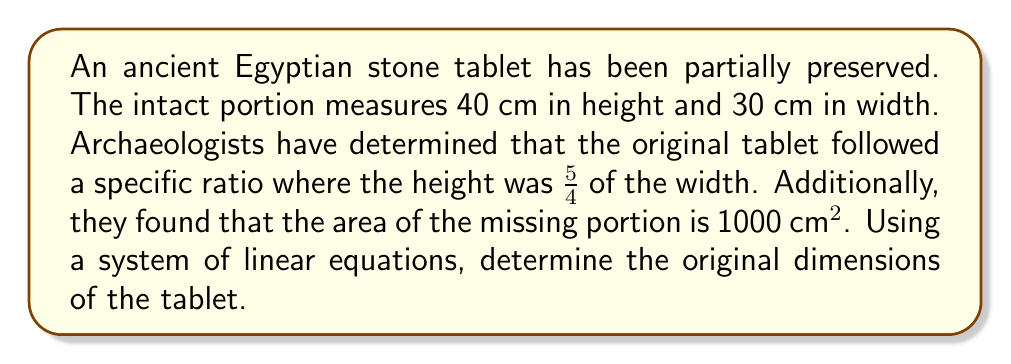Can you answer this question? Let's approach this step-by-step using a system of linear equations:

1) Let $x$ be the original width and $y$ be the original height of the tablet.

2) Given the ratio information, we can write our first equation:
   $$y = \frac{5}{4}x$$

3) We know the preserved portion is 40 cm in height and 30 cm in width. The missing portion's width is $(x - 30)$ and height is $(y - 40)$.

4) The area of the missing portion is 1000 cm². We can express this as our second equation:
   $$(x - 30)(y - 40) = 1000$$

5) Substitute the first equation into the second:
   $$(x - 30)(\frac{5}{4}x - 40) = 1000$$

6) Expand the equation:
   $$\frac{5}{4}x^2 - 40x - 30\cdot\frac{5}{4}x + 1200 = 1000$$
   $$\frac{5}{4}x^2 - \frac{190}{4}x + 200 = 0$$

7) Multiply all terms by 4 to eliminate fractions:
   $$5x^2 - 190x + 800 = 0$$

8) This is a quadratic equation. We can solve it using the quadratic formula:
   $$x = \frac{-b \pm \sqrt{b^2 - 4ac}}{2a}$$
   Where $a=5$, $b=-190$, and $c=800$

9) Solving:
   $$x = \frac{190 \pm \sqrt{36100 - 16000}}{10} = \frac{190 \pm \sqrt{20100}}{10}$$
   $$x = \frac{190 \pm 141.77}{10}$$

10) This gives us two solutions: $x ≈ 33.18$ or $x ≈ 4.82$
    Since the preserved portion is 30 cm wide, the original width must be greater than this. Therefore, $x ≈ 33.18$ cm.

11) To find the height, we use our original ratio equation:
    $$y = \frac{5}{4} \cdot 33.18 ≈ 41.475$$ cm

Therefore, the original dimensions were approximately 33.18 cm wide and 41.475 cm high.
Answer: 33.18 cm × 41.475 cm 